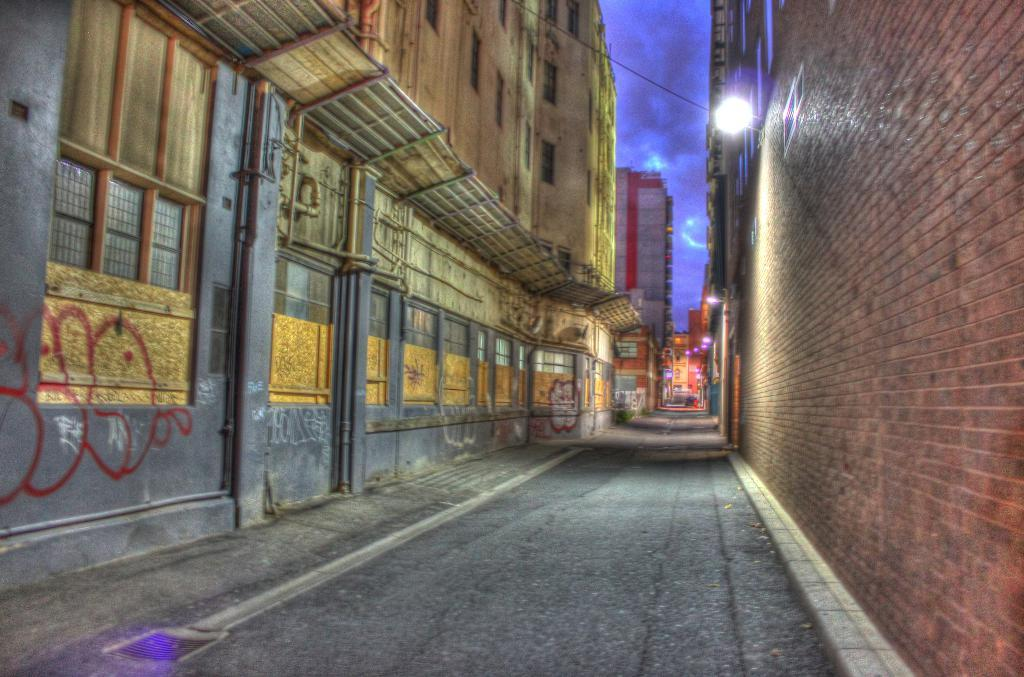What is the primary subject of the image? The primary subject of the image is the many buildings. Can you describe any specific features of the buildings? The provided facts do not mention any specific features of the buildings. What is attached to the wall in the image? There is a lamp on the wall in the image. How is the lamp connected to the wall? A cable is connected to the lamp. What is the weather like in the image? The sky is cloudy in the image. How does the stream flow through the buildings in the image? There is no stream present in the image; it only features buildings, a lamp, and a cable. 